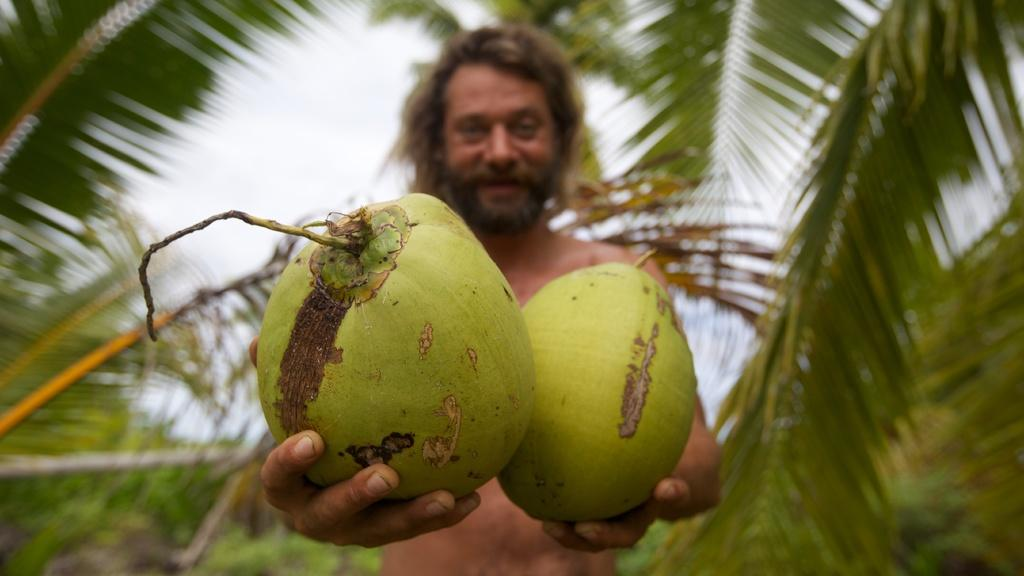Who is in the image? There is a person in the image. What is the person holding? The person is holding coconuts. Can you describe the background of the image? The background of the image is blurred. What type of vegetation can be seen in the background? There are palm trees in the background of the image. What else is visible in the background? The sky is visible in the background of the image. What is the person's opinion on the nerve of the picture? There is no mention of a nerve or a picture in the image, so it is not possible to determine the person's opinion on this topic. 